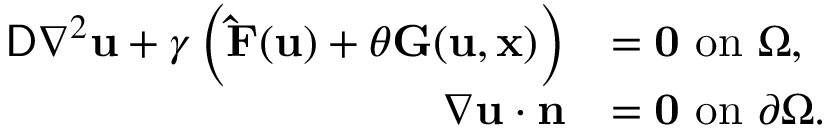Convert formula to latex. <formula><loc_0><loc_0><loc_500><loc_500>\begin{array} { r l } { D \nabla ^ { 2 } u + \gamma \left ( \hat { F } ( u ) + \theta G ( u , x ) \right ) } & { = 0 o n \Omega , } \\ { \nabla u \cdot n } & { = 0 o n \partial \Omega . } \end{array}</formula> 